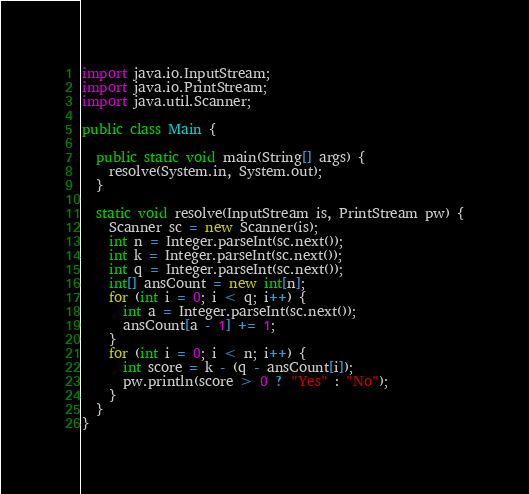<code> <loc_0><loc_0><loc_500><loc_500><_Java_>import java.io.InputStream;
import java.io.PrintStream;
import java.util.Scanner;

public class Main {

  public static void main(String[] args) {
    resolve(System.in, System.out);
  }

  static void resolve(InputStream is, PrintStream pw) {
    Scanner sc = new Scanner(is);
    int n = Integer.parseInt(sc.next());
    int k = Integer.parseInt(sc.next());
    int q = Integer.parseInt(sc.next());
    int[] ansCount = new int[n];
    for (int i = 0; i < q; i++) {
      int a = Integer.parseInt(sc.next());
      ansCount[a - 1] += 1;
    }
    for (int i = 0; i < n; i++) {
      int score = k - (q - ansCount[i]);
      pw.println(score > 0 ? "Yes" : "No");
    }
  }
}
</code> 